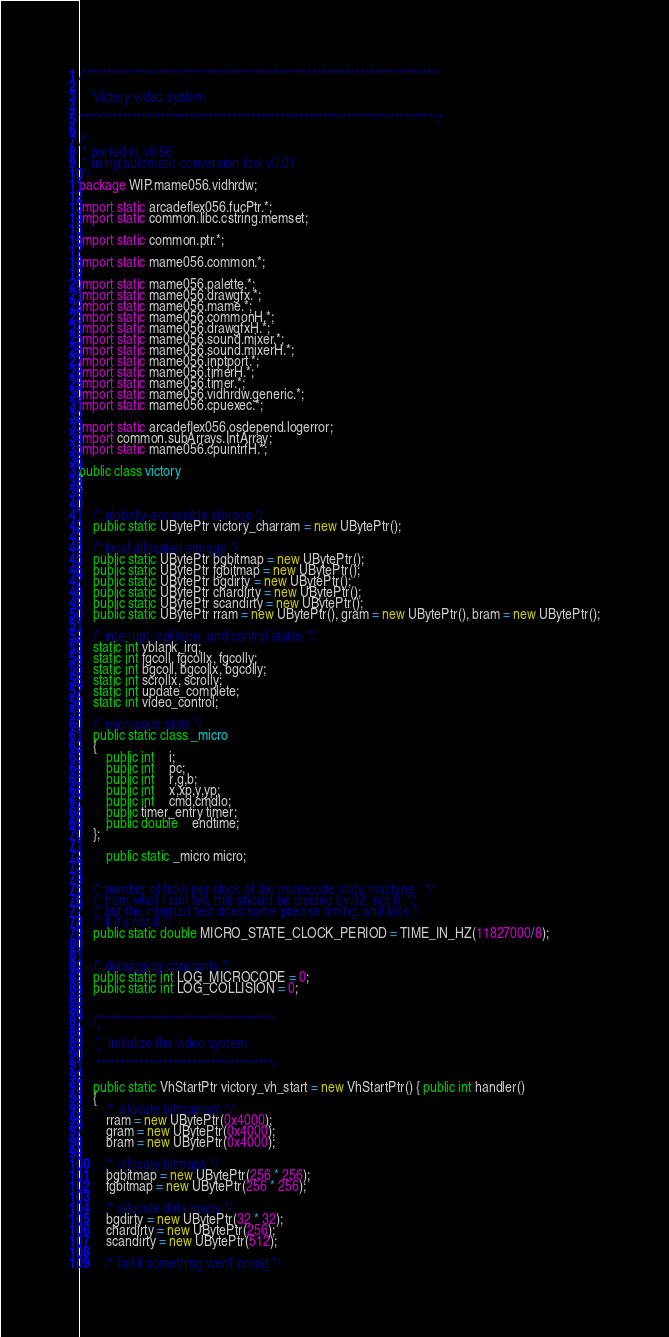<code> <loc_0><loc_0><loc_500><loc_500><_Java_>/***************************************************************************

	Victory video system

***************************************************************************/

/*
 * ported to v0.56
 * using automatic conversion tool v0.01
 */ 
package WIP.mame056.vidhrdw;

import static arcadeflex056.fucPtr.*;
import static common.libc.cstring.memset;

import static common.ptr.*;

import static mame056.common.*;

import static mame056.palette.*;
import static mame056.drawgfx.*;
import static mame056.mame.*;
import static mame056.commonH.*;
import static mame056.drawgfxH.*;
import static mame056.sound.mixer.*;
import static mame056.sound.mixerH.*;
import static mame056.inptport.*;
import static mame056.timerH.*;
import static mame056.timer.*;
import static mame056.vidhrdw.generic.*;
import static mame056.cpuexec.*;

import static arcadeflex056.osdepend.logerror;
import common.subArrays.IntArray;
import static mame056.cpuintrfH.*;

public class victory
{
	
	
	/* globally-accessible storage */
	public static UBytePtr victory_charram = new UBytePtr();
	
	/* local allocated storage */
	public static UBytePtr bgbitmap = new UBytePtr();
	public static UBytePtr fgbitmap = new UBytePtr();
	public static UBytePtr bgdirty = new UBytePtr();
	public static UBytePtr chardirty = new UBytePtr();
	public static UBytePtr scandirty = new UBytePtr();
	public static UBytePtr rram = new UBytePtr(), gram = new UBytePtr(), bram = new UBytePtr();
	
	/* interrupt, collision, and control states */
	static int vblank_irq;
	static int fgcoll, fgcollx, fgcolly;
	static int bgcoll, bgcollx, bgcolly;
	static int scrollx, scrolly;
	static int update_complete;
	static int video_control;
	
	/* microcode state */
	public static class _micro
	{
		public int	i;
		public int	pc;
		public int	r,g,b;
		public int	x,xp,y,yp;
		public int	cmd,cmdlo;
		public timer_entry timer;
		public double	endtime;
	};
        
        public static _micro micro;
	
	
	/* number of ticks per clock of the microcode state machine   */
	/* from what I can tell, this should be divided by 32, not 8  */
	/* but the interrupt test does some precise timing, and fails */
	/* if it's not 8 */
	public static double MICRO_STATE_CLOCK_PERIOD = TIME_IN_HZ(11827000/8);
	
	
	/* debugging constants */
	public static int LOG_MICROCODE = 0;
	public static int LOG_COLLISION = 0;
	
	
	/*************************************
	 *
	 *	Initialize the video system
	 *
	 *************************************/
	
	public static VhStartPtr victory_vh_start = new VhStartPtr() { public int handler() 
	{
		/* allocate bitmapram */
		rram = new UBytePtr(0x4000);
		gram = new UBytePtr(0x4000);
		bram = new UBytePtr(0x4000);
	
		/* allocate bitmaps */
		bgbitmap = new UBytePtr(256 * 256);
		fgbitmap = new UBytePtr(256 * 256);
	
		/* allocate dirty maps */
		bgdirty = new UBytePtr(32 * 32);
		chardirty = new UBytePtr(256);
		scandirty = new UBytePtr(512);
	
		/* fail if something went wrong */</code> 